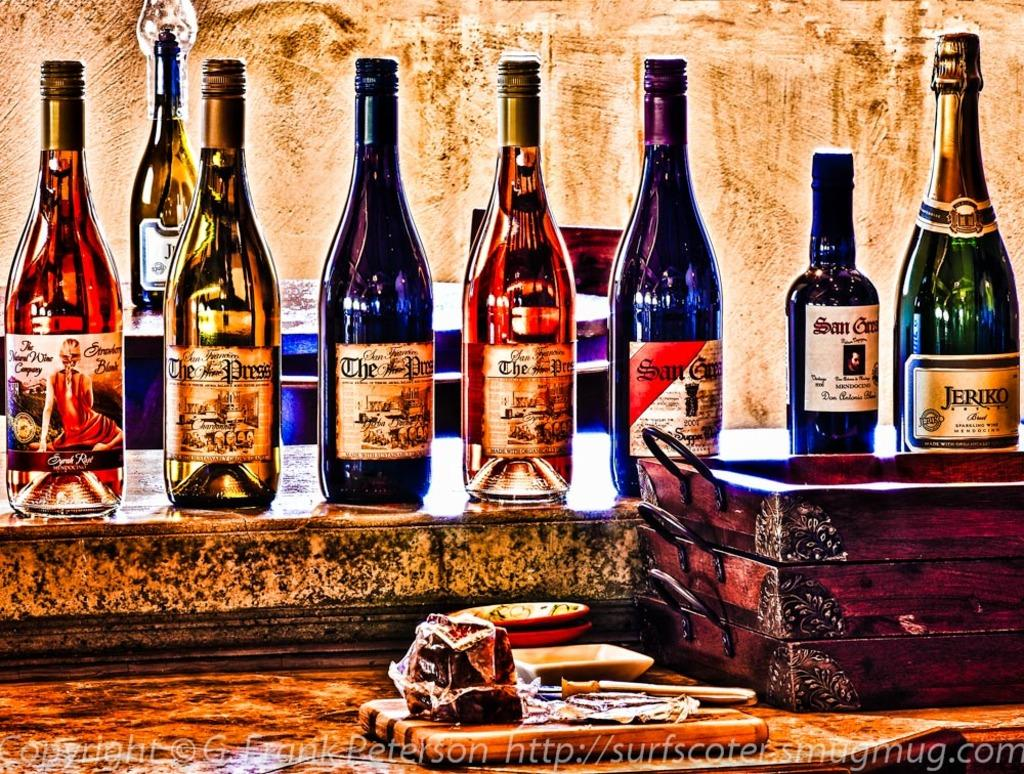<image>
Describe the image concisely. Among the various bottles of wine are two labeled The Wine Press. 